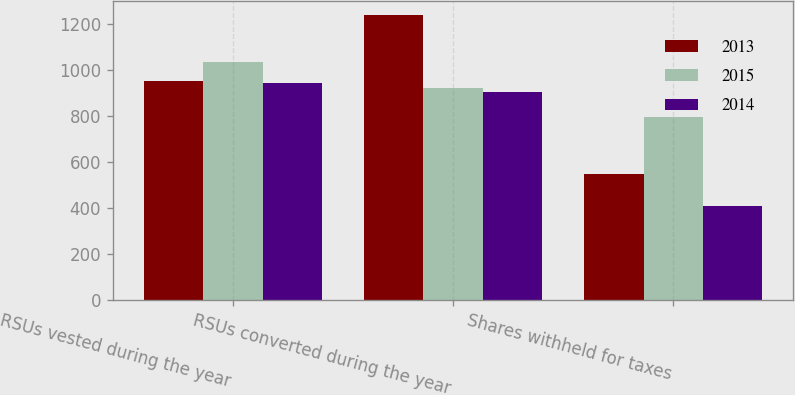<chart> <loc_0><loc_0><loc_500><loc_500><stacked_bar_chart><ecel><fcel>RSUs vested during the year<fcel>RSUs converted during the year<fcel>Shares withheld for taxes<nl><fcel>2013<fcel>954<fcel>1238<fcel>549<nl><fcel>2015<fcel>1037<fcel>923.5<fcel>796<nl><fcel>2014<fcel>942<fcel>905<fcel>407<nl></chart> 